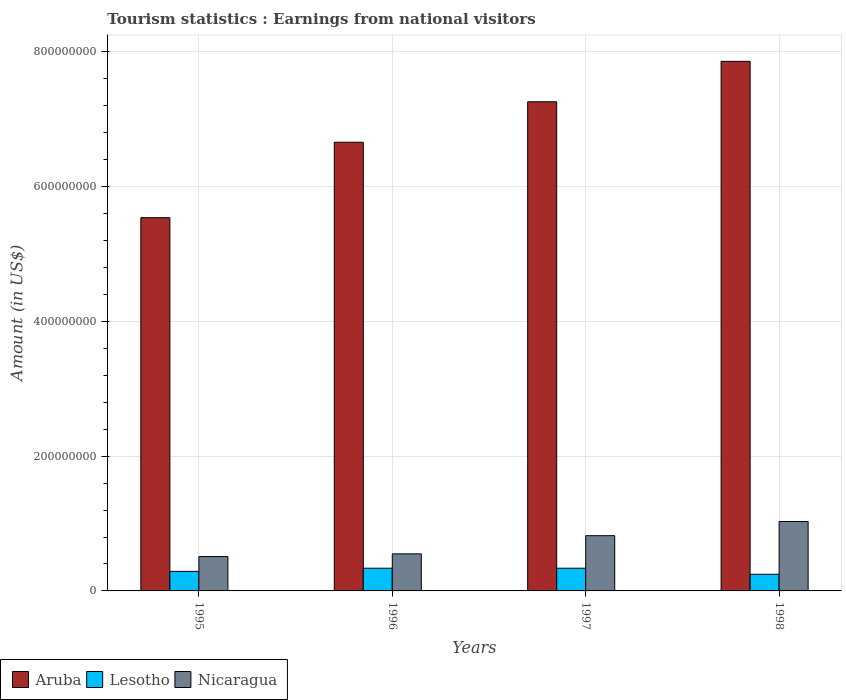How many groups of bars are there?
Give a very brief answer. 4. Are the number of bars per tick equal to the number of legend labels?
Give a very brief answer. Yes. How many bars are there on the 3rd tick from the left?
Keep it short and to the point. 3. What is the label of the 4th group of bars from the left?
Make the answer very short. 1998. What is the earnings from national visitors in Nicaragua in 1995?
Make the answer very short. 5.10e+07. Across all years, what is the maximum earnings from national visitors in Aruba?
Provide a succinct answer. 7.86e+08. Across all years, what is the minimum earnings from national visitors in Nicaragua?
Offer a very short reply. 5.10e+07. In which year was the earnings from national visitors in Lesotho maximum?
Offer a very short reply. 1996. What is the total earnings from national visitors in Nicaragua in the graph?
Your response must be concise. 2.91e+08. What is the difference between the earnings from national visitors in Lesotho in 1995 and that in 1998?
Make the answer very short. 4.30e+06. What is the difference between the earnings from national visitors in Lesotho in 1998 and the earnings from national visitors in Aruba in 1995?
Your answer should be compact. -5.29e+08. What is the average earnings from national visitors in Aruba per year?
Make the answer very short. 6.83e+08. In the year 1996, what is the difference between the earnings from national visitors in Aruba and earnings from national visitors in Lesotho?
Provide a succinct answer. 6.32e+08. In how many years, is the earnings from national visitors in Lesotho greater than 640000000 US$?
Ensure brevity in your answer.  0. What is the ratio of the earnings from national visitors in Nicaragua in 1995 to that in 1998?
Offer a terse response. 0.5. Is the difference between the earnings from national visitors in Aruba in 1996 and 1997 greater than the difference between the earnings from national visitors in Lesotho in 1996 and 1997?
Your answer should be very brief. No. What is the difference between the highest and the lowest earnings from national visitors in Nicaragua?
Your answer should be compact. 5.20e+07. In how many years, is the earnings from national visitors in Lesotho greater than the average earnings from national visitors in Lesotho taken over all years?
Ensure brevity in your answer.  2. Is the sum of the earnings from national visitors in Lesotho in 1995 and 1998 greater than the maximum earnings from national visitors in Nicaragua across all years?
Offer a very short reply. No. What does the 3rd bar from the left in 1996 represents?
Keep it short and to the point. Nicaragua. What does the 1st bar from the right in 1996 represents?
Offer a terse response. Nicaragua. Is it the case that in every year, the sum of the earnings from national visitors in Aruba and earnings from national visitors in Nicaragua is greater than the earnings from national visitors in Lesotho?
Ensure brevity in your answer.  Yes. How many bars are there?
Keep it short and to the point. 12. Are all the bars in the graph horizontal?
Give a very brief answer. No. Does the graph contain any zero values?
Provide a succinct answer. No. How are the legend labels stacked?
Give a very brief answer. Horizontal. What is the title of the graph?
Make the answer very short. Tourism statistics : Earnings from national visitors. What is the label or title of the X-axis?
Keep it short and to the point. Years. What is the Amount (in US$) of Aruba in 1995?
Ensure brevity in your answer.  5.54e+08. What is the Amount (in US$) of Lesotho in 1995?
Keep it short and to the point. 2.90e+07. What is the Amount (in US$) of Nicaragua in 1995?
Make the answer very short. 5.10e+07. What is the Amount (in US$) of Aruba in 1996?
Ensure brevity in your answer.  6.66e+08. What is the Amount (in US$) in Lesotho in 1996?
Ensure brevity in your answer.  3.37e+07. What is the Amount (in US$) of Nicaragua in 1996?
Give a very brief answer. 5.50e+07. What is the Amount (in US$) in Aruba in 1997?
Offer a terse response. 7.26e+08. What is the Amount (in US$) of Lesotho in 1997?
Ensure brevity in your answer.  3.37e+07. What is the Amount (in US$) in Nicaragua in 1997?
Your answer should be very brief. 8.20e+07. What is the Amount (in US$) in Aruba in 1998?
Your answer should be very brief. 7.86e+08. What is the Amount (in US$) in Lesotho in 1998?
Make the answer very short. 2.47e+07. What is the Amount (in US$) of Nicaragua in 1998?
Your answer should be very brief. 1.03e+08. Across all years, what is the maximum Amount (in US$) in Aruba?
Provide a short and direct response. 7.86e+08. Across all years, what is the maximum Amount (in US$) in Lesotho?
Provide a short and direct response. 3.37e+07. Across all years, what is the maximum Amount (in US$) in Nicaragua?
Your answer should be compact. 1.03e+08. Across all years, what is the minimum Amount (in US$) in Aruba?
Ensure brevity in your answer.  5.54e+08. Across all years, what is the minimum Amount (in US$) in Lesotho?
Provide a short and direct response. 2.47e+07. Across all years, what is the minimum Amount (in US$) in Nicaragua?
Keep it short and to the point. 5.10e+07. What is the total Amount (in US$) of Aruba in the graph?
Make the answer very short. 2.73e+09. What is the total Amount (in US$) of Lesotho in the graph?
Keep it short and to the point. 1.21e+08. What is the total Amount (in US$) in Nicaragua in the graph?
Your answer should be compact. 2.91e+08. What is the difference between the Amount (in US$) in Aruba in 1995 and that in 1996?
Your response must be concise. -1.12e+08. What is the difference between the Amount (in US$) in Lesotho in 1995 and that in 1996?
Offer a terse response. -4.70e+06. What is the difference between the Amount (in US$) in Nicaragua in 1995 and that in 1996?
Provide a short and direct response. -4.00e+06. What is the difference between the Amount (in US$) of Aruba in 1995 and that in 1997?
Give a very brief answer. -1.72e+08. What is the difference between the Amount (in US$) in Lesotho in 1995 and that in 1997?
Your response must be concise. -4.70e+06. What is the difference between the Amount (in US$) in Nicaragua in 1995 and that in 1997?
Give a very brief answer. -3.10e+07. What is the difference between the Amount (in US$) of Aruba in 1995 and that in 1998?
Provide a succinct answer. -2.32e+08. What is the difference between the Amount (in US$) of Lesotho in 1995 and that in 1998?
Your response must be concise. 4.30e+06. What is the difference between the Amount (in US$) of Nicaragua in 1995 and that in 1998?
Keep it short and to the point. -5.20e+07. What is the difference between the Amount (in US$) in Aruba in 1996 and that in 1997?
Offer a very short reply. -6.00e+07. What is the difference between the Amount (in US$) in Nicaragua in 1996 and that in 1997?
Offer a terse response. -2.70e+07. What is the difference between the Amount (in US$) of Aruba in 1996 and that in 1998?
Your answer should be compact. -1.20e+08. What is the difference between the Amount (in US$) of Lesotho in 1996 and that in 1998?
Your response must be concise. 9.00e+06. What is the difference between the Amount (in US$) of Nicaragua in 1996 and that in 1998?
Provide a succinct answer. -4.80e+07. What is the difference between the Amount (in US$) in Aruba in 1997 and that in 1998?
Give a very brief answer. -6.00e+07. What is the difference between the Amount (in US$) of Lesotho in 1997 and that in 1998?
Ensure brevity in your answer.  9.00e+06. What is the difference between the Amount (in US$) of Nicaragua in 1997 and that in 1998?
Your response must be concise. -2.10e+07. What is the difference between the Amount (in US$) of Aruba in 1995 and the Amount (in US$) of Lesotho in 1996?
Offer a very short reply. 5.20e+08. What is the difference between the Amount (in US$) of Aruba in 1995 and the Amount (in US$) of Nicaragua in 1996?
Offer a terse response. 4.99e+08. What is the difference between the Amount (in US$) of Lesotho in 1995 and the Amount (in US$) of Nicaragua in 1996?
Your response must be concise. -2.60e+07. What is the difference between the Amount (in US$) of Aruba in 1995 and the Amount (in US$) of Lesotho in 1997?
Offer a very short reply. 5.20e+08. What is the difference between the Amount (in US$) in Aruba in 1995 and the Amount (in US$) in Nicaragua in 1997?
Ensure brevity in your answer.  4.72e+08. What is the difference between the Amount (in US$) in Lesotho in 1995 and the Amount (in US$) in Nicaragua in 1997?
Your answer should be very brief. -5.30e+07. What is the difference between the Amount (in US$) of Aruba in 1995 and the Amount (in US$) of Lesotho in 1998?
Provide a succinct answer. 5.29e+08. What is the difference between the Amount (in US$) of Aruba in 1995 and the Amount (in US$) of Nicaragua in 1998?
Provide a short and direct response. 4.51e+08. What is the difference between the Amount (in US$) in Lesotho in 1995 and the Amount (in US$) in Nicaragua in 1998?
Offer a terse response. -7.40e+07. What is the difference between the Amount (in US$) of Aruba in 1996 and the Amount (in US$) of Lesotho in 1997?
Offer a very short reply. 6.32e+08. What is the difference between the Amount (in US$) of Aruba in 1996 and the Amount (in US$) of Nicaragua in 1997?
Make the answer very short. 5.84e+08. What is the difference between the Amount (in US$) of Lesotho in 1996 and the Amount (in US$) of Nicaragua in 1997?
Ensure brevity in your answer.  -4.83e+07. What is the difference between the Amount (in US$) in Aruba in 1996 and the Amount (in US$) in Lesotho in 1998?
Offer a very short reply. 6.41e+08. What is the difference between the Amount (in US$) of Aruba in 1996 and the Amount (in US$) of Nicaragua in 1998?
Your answer should be compact. 5.63e+08. What is the difference between the Amount (in US$) of Lesotho in 1996 and the Amount (in US$) of Nicaragua in 1998?
Your answer should be very brief. -6.93e+07. What is the difference between the Amount (in US$) of Aruba in 1997 and the Amount (in US$) of Lesotho in 1998?
Your response must be concise. 7.01e+08. What is the difference between the Amount (in US$) in Aruba in 1997 and the Amount (in US$) in Nicaragua in 1998?
Your answer should be very brief. 6.23e+08. What is the difference between the Amount (in US$) in Lesotho in 1997 and the Amount (in US$) in Nicaragua in 1998?
Offer a very short reply. -6.93e+07. What is the average Amount (in US$) of Aruba per year?
Give a very brief answer. 6.83e+08. What is the average Amount (in US$) in Lesotho per year?
Provide a short and direct response. 3.03e+07. What is the average Amount (in US$) in Nicaragua per year?
Your answer should be compact. 7.28e+07. In the year 1995, what is the difference between the Amount (in US$) in Aruba and Amount (in US$) in Lesotho?
Provide a short and direct response. 5.25e+08. In the year 1995, what is the difference between the Amount (in US$) of Aruba and Amount (in US$) of Nicaragua?
Your answer should be very brief. 5.03e+08. In the year 1995, what is the difference between the Amount (in US$) in Lesotho and Amount (in US$) in Nicaragua?
Your answer should be very brief. -2.20e+07. In the year 1996, what is the difference between the Amount (in US$) of Aruba and Amount (in US$) of Lesotho?
Ensure brevity in your answer.  6.32e+08. In the year 1996, what is the difference between the Amount (in US$) in Aruba and Amount (in US$) in Nicaragua?
Your response must be concise. 6.11e+08. In the year 1996, what is the difference between the Amount (in US$) of Lesotho and Amount (in US$) of Nicaragua?
Your answer should be very brief. -2.13e+07. In the year 1997, what is the difference between the Amount (in US$) in Aruba and Amount (in US$) in Lesotho?
Your answer should be very brief. 6.92e+08. In the year 1997, what is the difference between the Amount (in US$) of Aruba and Amount (in US$) of Nicaragua?
Provide a short and direct response. 6.44e+08. In the year 1997, what is the difference between the Amount (in US$) in Lesotho and Amount (in US$) in Nicaragua?
Your answer should be compact. -4.83e+07. In the year 1998, what is the difference between the Amount (in US$) in Aruba and Amount (in US$) in Lesotho?
Provide a succinct answer. 7.61e+08. In the year 1998, what is the difference between the Amount (in US$) of Aruba and Amount (in US$) of Nicaragua?
Your answer should be compact. 6.83e+08. In the year 1998, what is the difference between the Amount (in US$) of Lesotho and Amount (in US$) of Nicaragua?
Your answer should be compact. -7.83e+07. What is the ratio of the Amount (in US$) in Aruba in 1995 to that in 1996?
Provide a short and direct response. 0.83. What is the ratio of the Amount (in US$) in Lesotho in 1995 to that in 1996?
Your answer should be compact. 0.86. What is the ratio of the Amount (in US$) of Nicaragua in 1995 to that in 1996?
Offer a very short reply. 0.93. What is the ratio of the Amount (in US$) of Aruba in 1995 to that in 1997?
Keep it short and to the point. 0.76. What is the ratio of the Amount (in US$) in Lesotho in 1995 to that in 1997?
Give a very brief answer. 0.86. What is the ratio of the Amount (in US$) in Nicaragua in 1995 to that in 1997?
Provide a succinct answer. 0.62. What is the ratio of the Amount (in US$) in Aruba in 1995 to that in 1998?
Make the answer very short. 0.7. What is the ratio of the Amount (in US$) of Lesotho in 1995 to that in 1998?
Provide a short and direct response. 1.17. What is the ratio of the Amount (in US$) in Nicaragua in 1995 to that in 1998?
Provide a succinct answer. 0.5. What is the ratio of the Amount (in US$) of Aruba in 1996 to that in 1997?
Keep it short and to the point. 0.92. What is the ratio of the Amount (in US$) in Lesotho in 1996 to that in 1997?
Offer a terse response. 1. What is the ratio of the Amount (in US$) in Nicaragua in 1996 to that in 1997?
Provide a short and direct response. 0.67. What is the ratio of the Amount (in US$) of Aruba in 1996 to that in 1998?
Give a very brief answer. 0.85. What is the ratio of the Amount (in US$) of Lesotho in 1996 to that in 1998?
Provide a succinct answer. 1.36. What is the ratio of the Amount (in US$) in Nicaragua in 1996 to that in 1998?
Provide a succinct answer. 0.53. What is the ratio of the Amount (in US$) in Aruba in 1997 to that in 1998?
Your response must be concise. 0.92. What is the ratio of the Amount (in US$) of Lesotho in 1997 to that in 1998?
Make the answer very short. 1.36. What is the ratio of the Amount (in US$) of Nicaragua in 1997 to that in 1998?
Offer a very short reply. 0.8. What is the difference between the highest and the second highest Amount (in US$) in Aruba?
Offer a very short reply. 6.00e+07. What is the difference between the highest and the second highest Amount (in US$) in Nicaragua?
Give a very brief answer. 2.10e+07. What is the difference between the highest and the lowest Amount (in US$) in Aruba?
Give a very brief answer. 2.32e+08. What is the difference between the highest and the lowest Amount (in US$) of Lesotho?
Offer a very short reply. 9.00e+06. What is the difference between the highest and the lowest Amount (in US$) of Nicaragua?
Offer a terse response. 5.20e+07. 